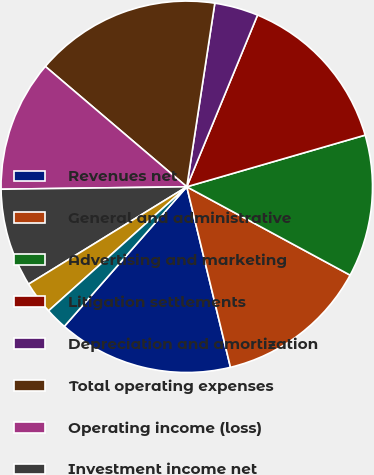Convert chart to OTSL. <chart><loc_0><loc_0><loc_500><loc_500><pie_chart><fcel>Revenues net<fcel>General and administrative<fcel>Advertising and marketing<fcel>Litigation settlements<fcel>Depreciation and amortization<fcel>Total operating expenses<fcel>Operating income (loss)<fcel>Investment income net<fcel>Interest expense<fcel>Other income (expense) net<nl><fcel>15.24%<fcel>13.33%<fcel>12.38%<fcel>14.29%<fcel>3.81%<fcel>16.19%<fcel>11.43%<fcel>8.57%<fcel>2.86%<fcel>1.9%<nl></chart> 